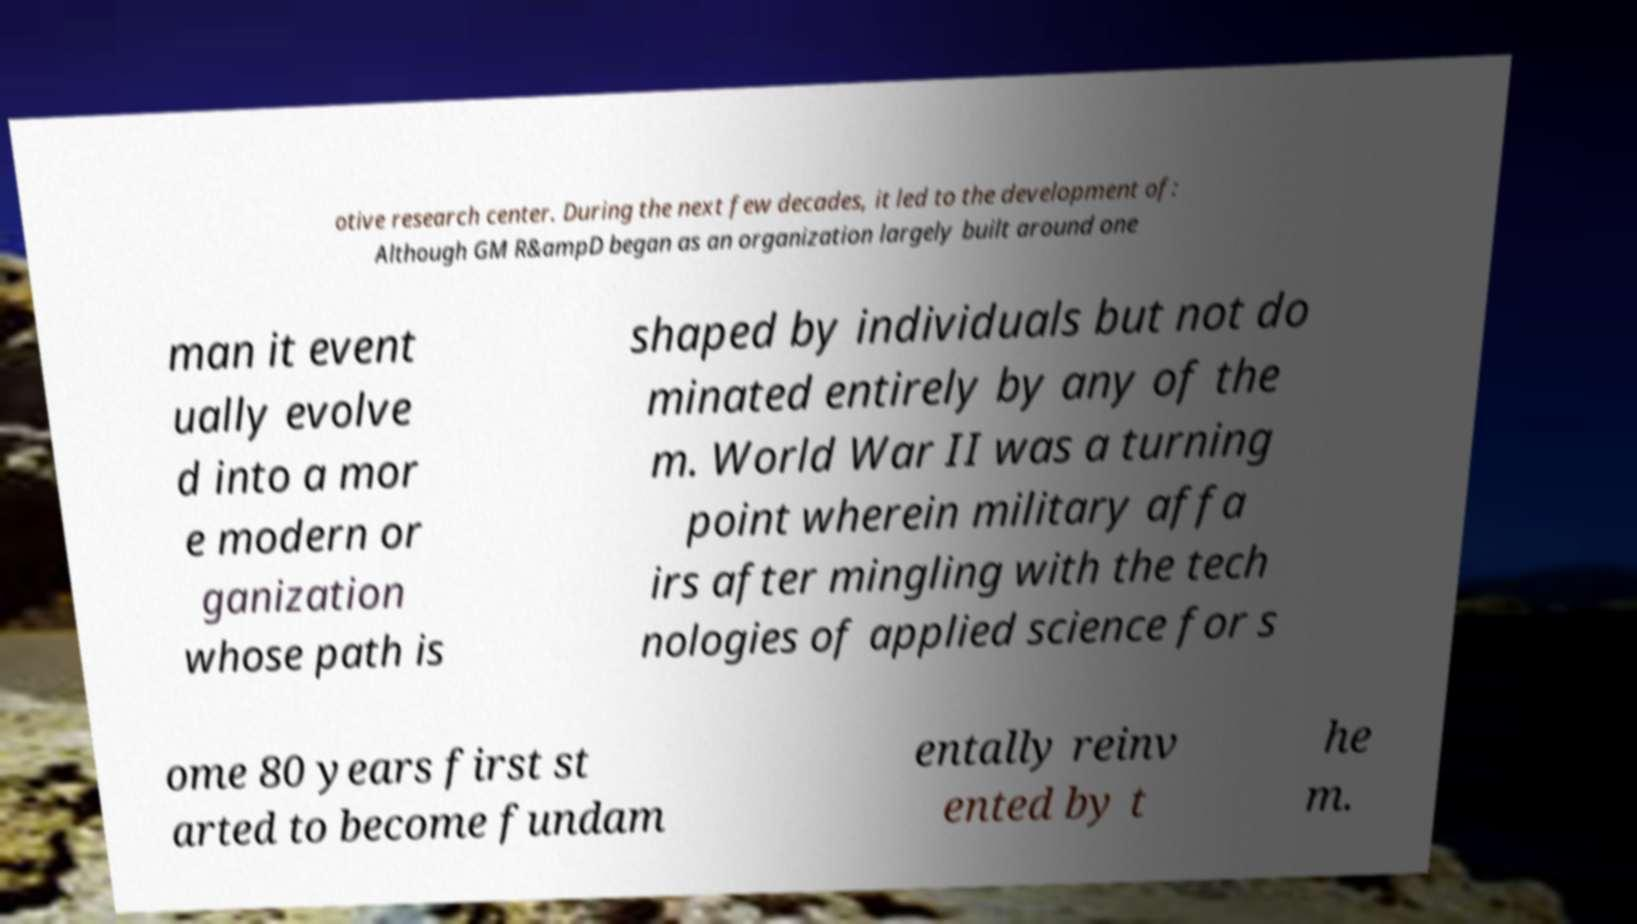Could you assist in decoding the text presented in this image and type it out clearly? otive research center. During the next few decades, it led to the development of: Although GM R&ampD began as an organization largely built around one man it event ually evolve d into a mor e modern or ganization whose path is shaped by individuals but not do minated entirely by any of the m. World War II was a turning point wherein military affa irs after mingling with the tech nologies of applied science for s ome 80 years first st arted to become fundam entally reinv ented by t he m. 